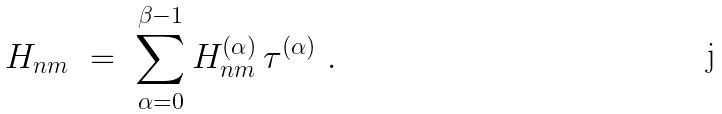<formula> <loc_0><loc_0><loc_500><loc_500>H _ { n m } \ = \ \sum _ { \alpha = 0 } ^ { \beta - 1 } H _ { n m } ^ { ( \alpha ) } \, \tau ^ { ( \alpha ) } \ .</formula> 